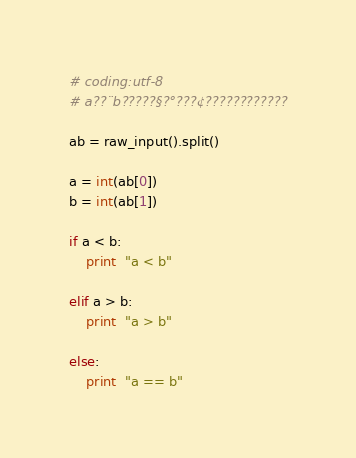Convert code to text. <code><loc_0><loc_0><loc_500><loc_500><_Python_># coding:utf-8
# a??¨b?????§?°???¢????????????

ab = raw_input().split()

a = int(ab[0])
b = int(ab[1])

if a < b:
    print  "a < b"

elif a > b:
    print  "a > b"

else:
    print  "a == b"</code> 